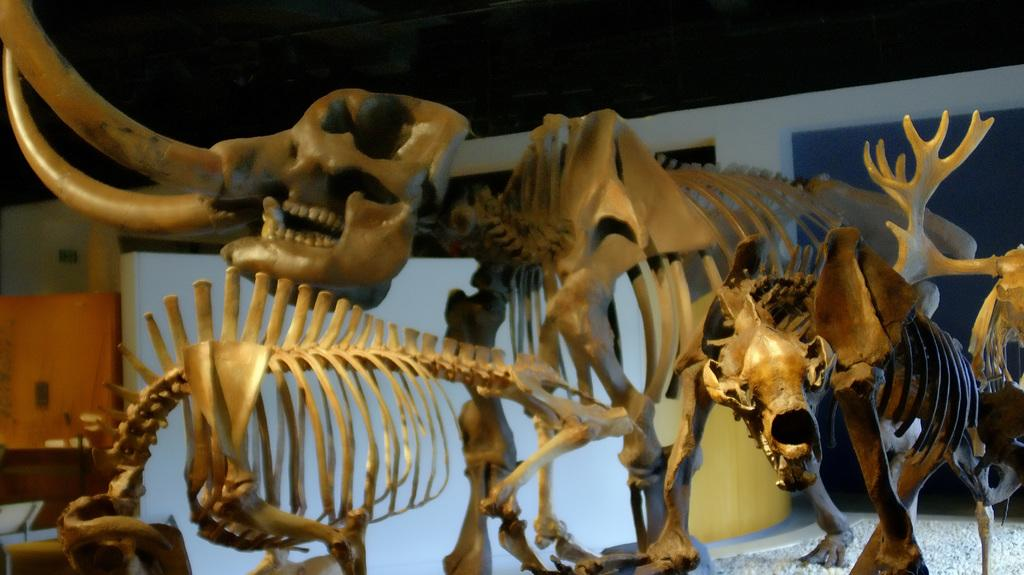What type of objects can be seen in the image? There are animal skeletons in the image. What is located on the left side of the image? There appears to be a wall on the left side of the image. What can be inferred about the setting of the image? The image seems to depict an inner view of a room. What type of meat can be seen hanging from the wrist in the image? There is no meat or wrist present in the image; it features animal skeletons and a wall. 